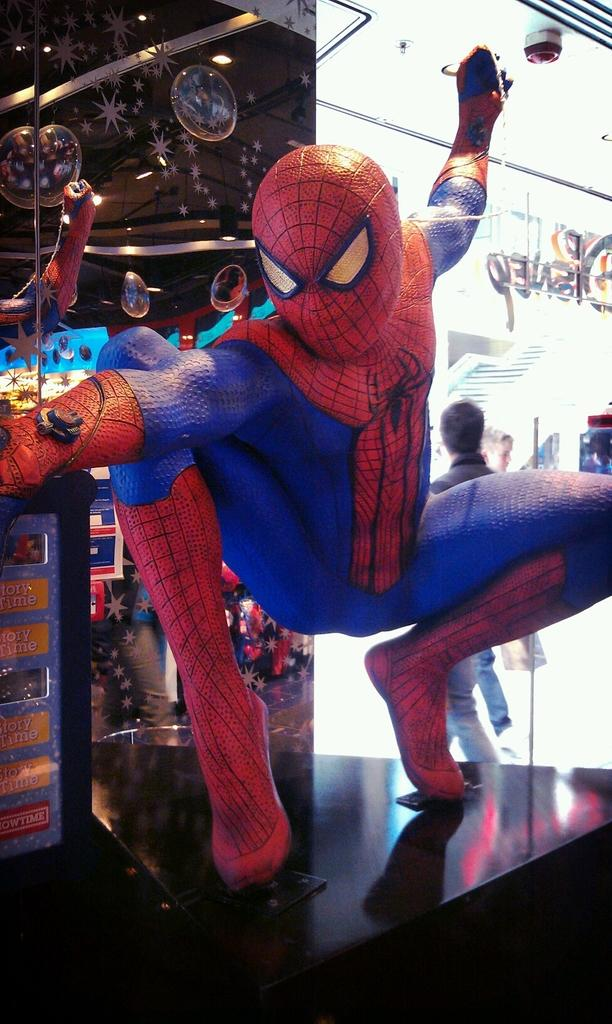What is the main subject of the image? There is a Spider-Man statue in the image. Can you describe the background of the image? There are two persons in the background of the image. What is located on the left side of the image? There is a glass and a board on the left side of the image. What type of flavor can be tasted in the zoo depicted in the image? There is no zoo present in the image, and therefore no flavor can be tasted. How many feet are visible on the persons in the image? The image does not show the feet of the persons in the background, so it cannot be determined how many feet are visible. 